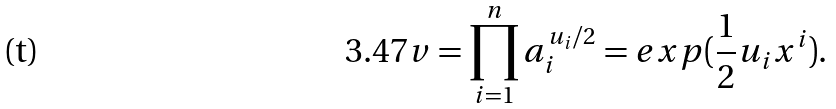Convert formula to latex. <formula><loc_0><loc_0><loc_500><loc_500>3 . 4 7 v = \prod _ { i = 1 } ^ { n } a _ { i } ^ { u _ { i } / 2 } = e x p ( \frac { 1 } { 2 } u _ { i } x ^ { i } ) .</formula> 